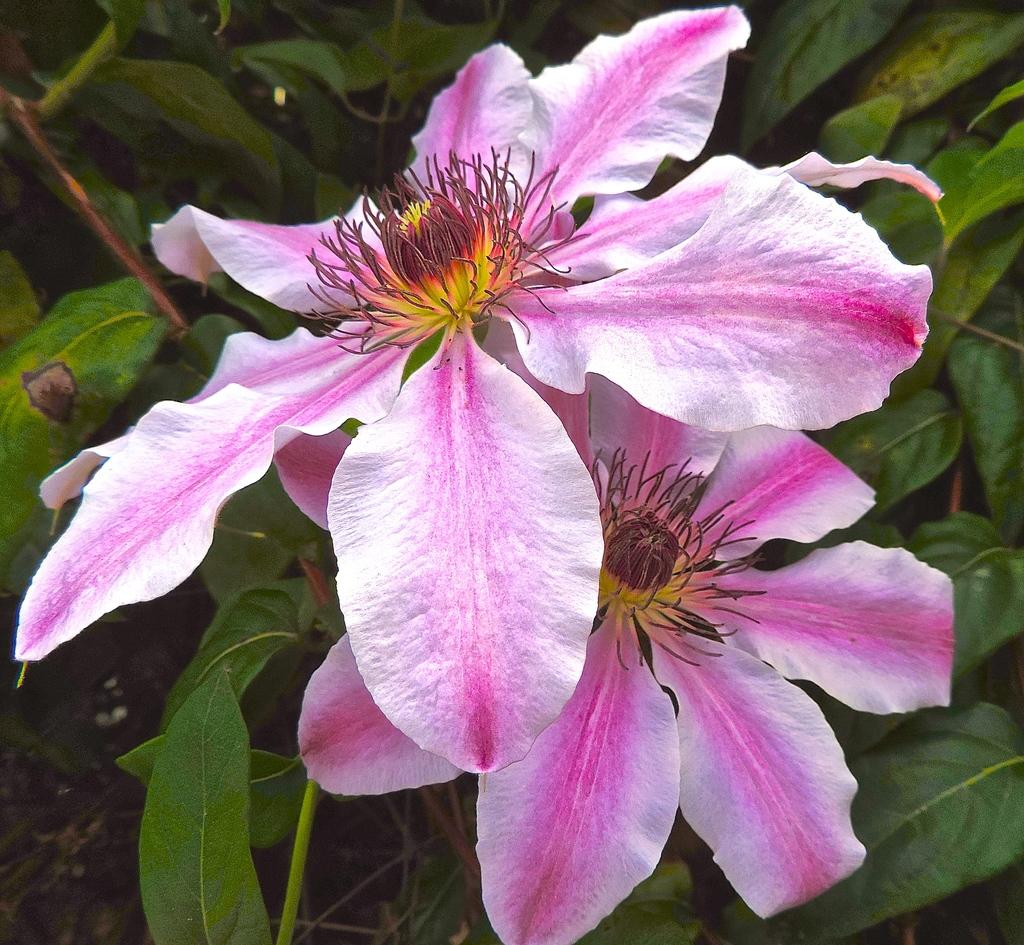What type of flora can be seen in the image? There are colorful flowers in the image. Are there any other types of plants visible in the image? Yes, there are plants in the image. What type of business is being conducted on the stage in the image? There is no stage or business present in the image; it features colorful flowers and plants. What type of seed is used to grow the flowers in the image? There is no information about the type of seed used to grow the flowers in the image. 